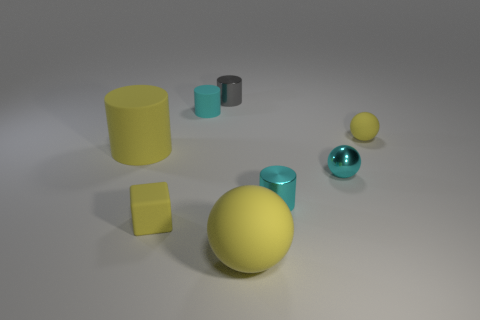There is a cyan cylinder behind the small cyan sphere; does it have the same size as the yellow rubber sphere that is in front of the big cylinder?
Make the answer very short. No. There is a block; is its size the same as the yellow rubber sphere that is on the left side of the tiny metal sphere?
Provide a short and direct response. No. Does the metallic sphere have the same size as the yellow matte cylinder?
Your answer should be compact. No. There is a block that is the same size as the cyan matte cylinder; what is it made of?
Provide a succinct answer. Rubber. What number of tiny cyan metal things are the same shape as the small gray object?
Your answer should be very brief. 1. There is a yellow cylinder that is made of the same material as the large ball; what size is it?
Your answer should be compact. Large. There is a yellow thing that is both in front of the large cylinder and to the right of the gray metal cylinder; what material is it made of?
Keep it short and to the point. Rubber. How many yellow matte blocks are the same size as the cyan rubber object?
Your answer should be very brief. 1. There is a gray thing that is the same shape as the cyan matte object; what material is it?
Keep it short and to the point. Metal. What number of objects are big objects that are to the right of the rubber cube or rubber things behind the tiny cube?
Make the answer very short. 4. 